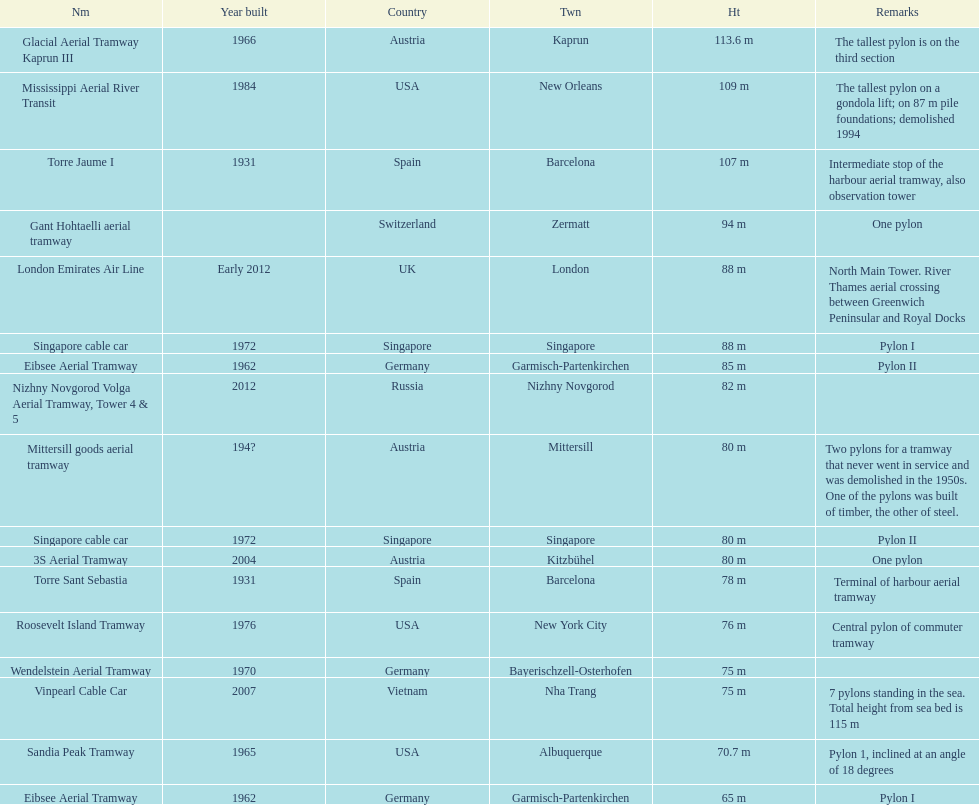What year was the last pylon in germany built? 1970. 